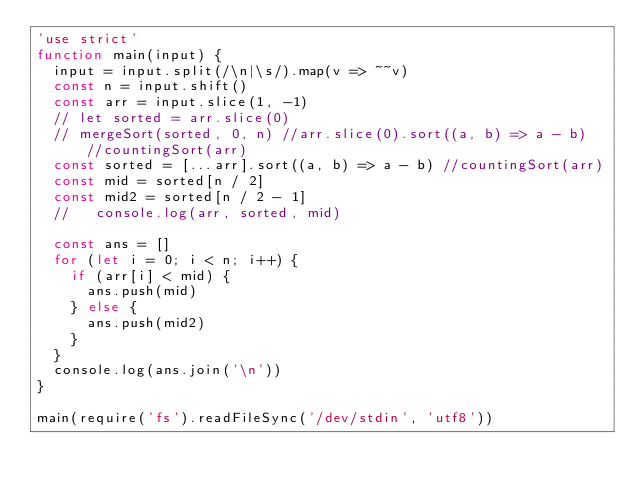Convert code to text. <code><loc_0><loc_0><loc_500><loc_500><_JavaScript_>'use strict'
function main(input) {
  input = input.split(/\n|\s/).map(v => ~~v)
  const n = input.shift()
  const arr = input.slice(1, -1)
  // let sorted = arr.slice(0)
  // mergeSort(sorted, 0, n) //arr.slice(0).sort((a, b) => a - b) //countingSort(arr)
  const sorted = [...arr].sort((a, b) => a - b) //countingSort(arr)
  const mid = sorted[n / 2]
  const mid2 = sorted[n / 2 - 1]
  //   console.log(arr, sorted, mid)

  const ans = []
  for (let i = 0; i < n; i++) {
    if (arr[i] < mid) {
      ans.push(mid)
    } else {
      ans.push(mid2)
    }
  }
  console.log(ans.join('\n'))
}

main(require('fs').readFileSync('/dev/stdin', 'utf8'))
</code> 